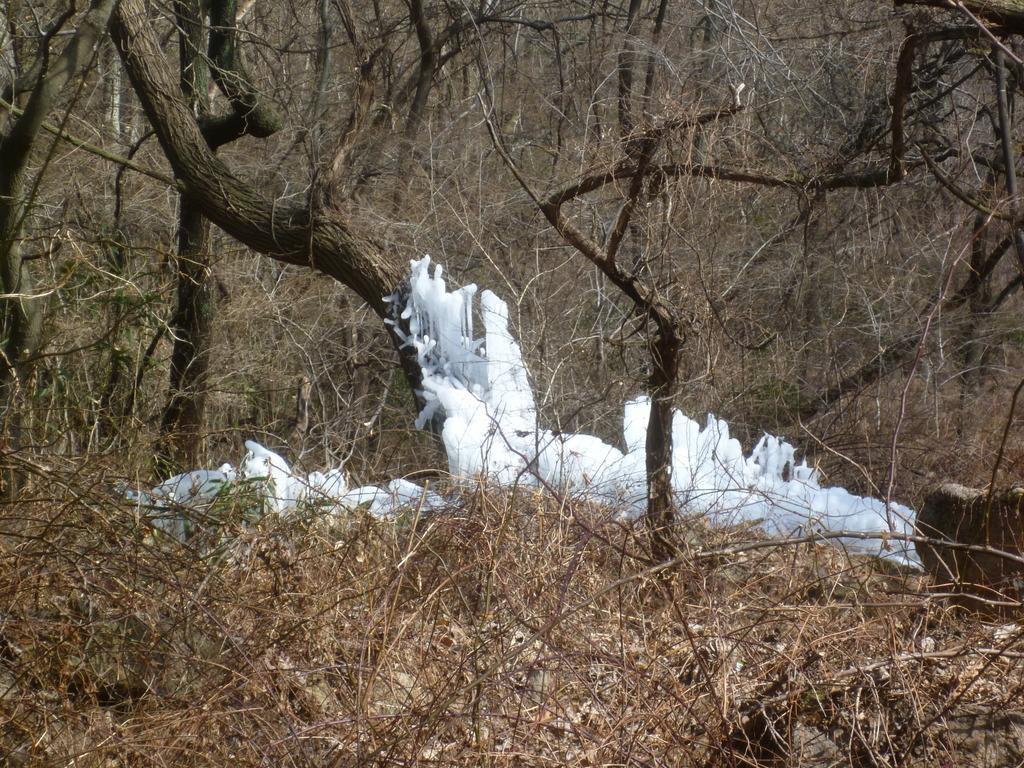How would you summarize this image in a sentence or two? The picture is taken inside a forest where trees are present and in the middle there is snow like structure is present. 